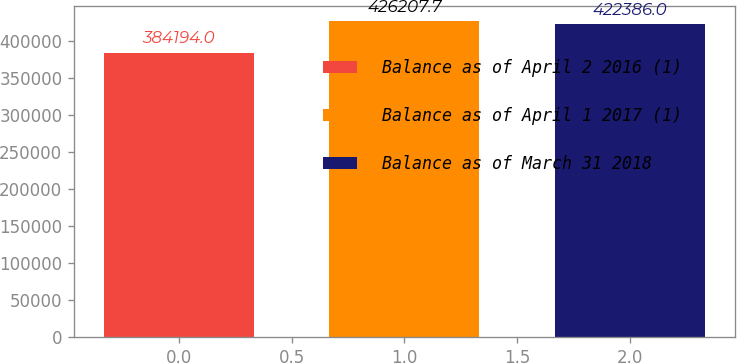Convert chart to OTSL. <chart><loc_0><loc_0><loc_500><loc_500><bar_chart><fcel>Balance as of April 2 2016 (1)<fcel>Balance as of April 1 2017 (1)<fcel>Balance as of March 31 2018<nl><fcel>384194<fcel>426208<fcel>422386<nl></chart> 